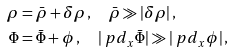<formula> <loc_0><loc_0><loc_500><loc_500>\rho & = \bar { \rho } + \delta \rho \, , \quad \bar { \rho } \gg | \delta \rho | \, , \\ \Phi & = \bar { \Phi } + \phi \, , \quad | \ p d _ { x } \bar { \Phi } | \gg | \ p d _ { x } \phi | \, ,</formula> 